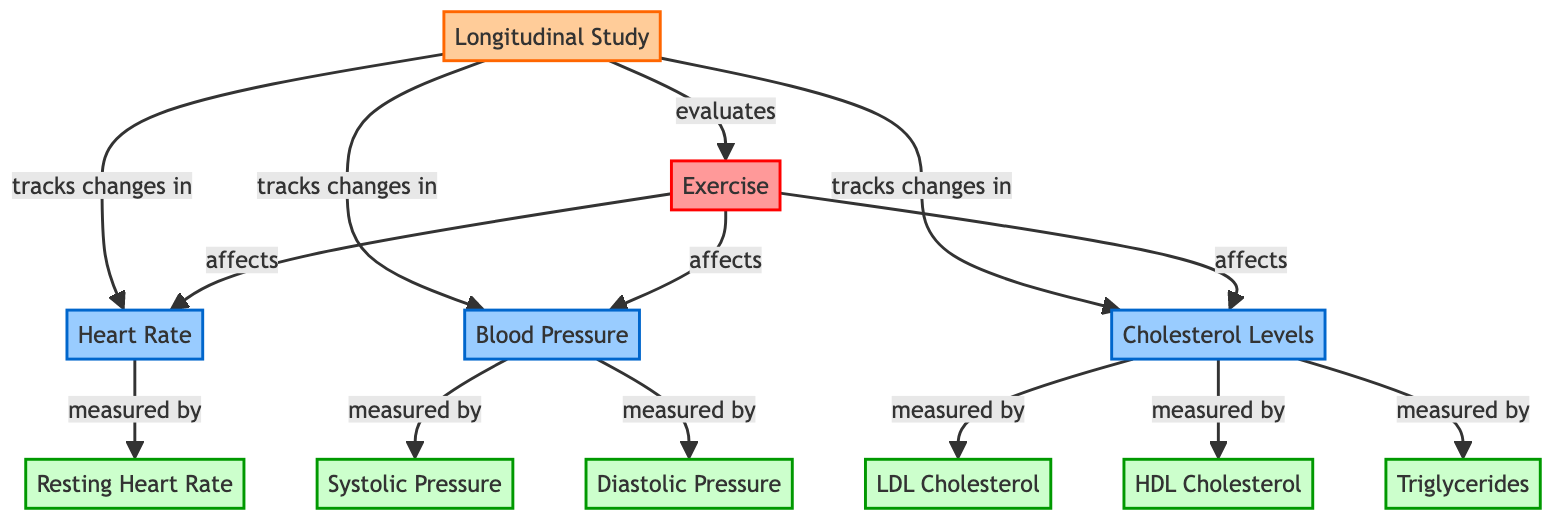What is the main intervention represented in the diagram? The main intervention shown in the diagram is the exercise node, which is highlighted in red and is the starting point for evaluating its impact on other biomarker nodes.
Answer: Exercise How many biomarkers are tracked in the study? The diagram shows four biomarker nodes: Heart Rate, Blood Pressure, and Cholesterol Levels. Therefore, the total count of biomarker nodes is four.
Answer: 4 What type of study design is referenced in the diagram? The methodology node at the top of the diagram clearly labels the type of study as a longitudinal study.
Answer: Longitudinal Study Which biomarker is primarily measured by resting heart rate? The diagram indicates that Heart Rate is measured by the Resting Heart Rate datapoint. Thus, Resting Heart Rate is specifically linked to Heart Rate.
Answer: Heart Rate What are the two types of cholesterol levels mentioned in the diagram? The cholesterol levels node indicates that there are two types being measured: LDL Cholesterol and HDL Cholesterol.
Answer: LDL Cholesterol and HDL Cholesterol How does exercise affect blood pressure according to the diagram? The diagram shows a direct connection where Exercise affects Blood Pressure, indicating that changes in exercise levels influence blood pressure metrics.
Answer: Affects What is the relationship between blood pressure and systolic pressure? The diagram specifies that Blood Pressure is measured by two datapoints: Systolic Pressure and Diastolic Pressure, thus creating a direct measurement relationship.
Answer: Measured by How is cholesterol level related to triglycerides? Although not explicitly stated, the cholesterol levels node is linked to Triglycerides as a measurement parameter, indicating that cholesterol levels impact this biomarker.
Answer: Measured by Which element of the diagram evaluates the entire impact of the exercise intervention? The Longitudinal Study node is the element responsible for evaluating the exercise intervention, as it tracks all changes in the biomarkers associated with exercise.
Answer: Longitudinal Study 